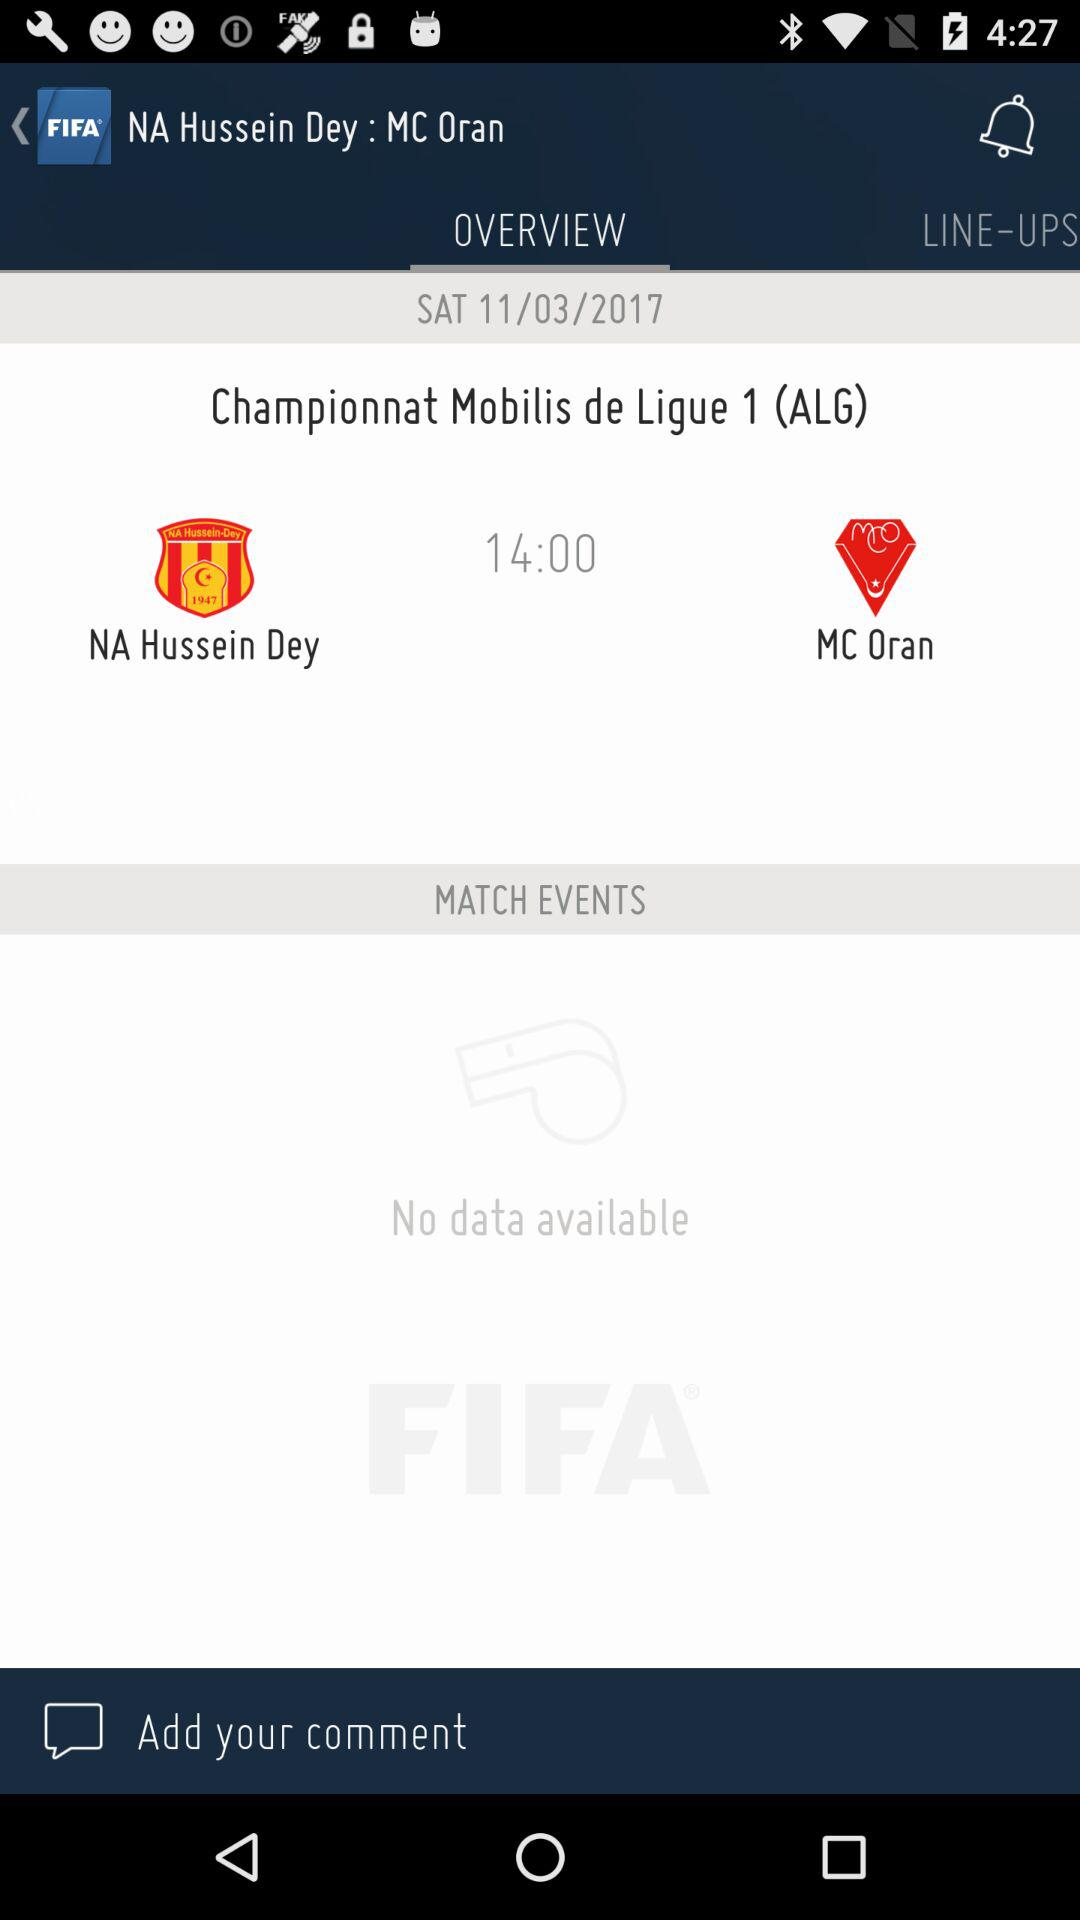How many teams are playing in this match?
Answer the question using a single word or phrase. 2 